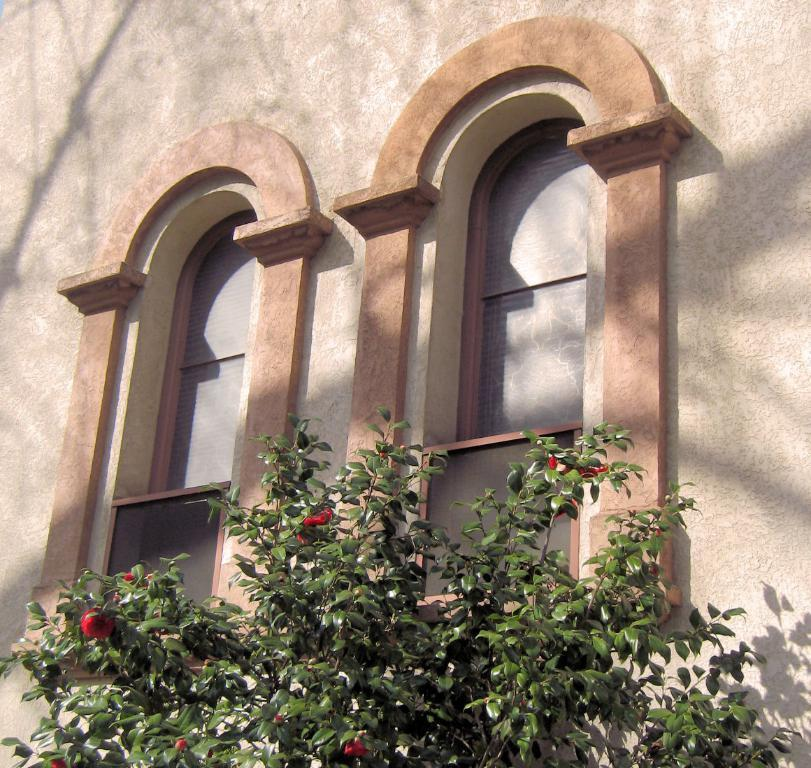What type of structure is visible in the image? There is a wall in the image. What can be seen on the wall in the image? There are windows in the image. What type of vegetation is present in the image? There is a plant with flowers in the image. What type of lunch is being served in the image? There is no lunch present in the image; it only features a wall, windows, and a plant with flowers. Can you read the letter that is being delivered in the image? There is no letter present in the image; it only features a wall, windows, and a plant with flowers. 